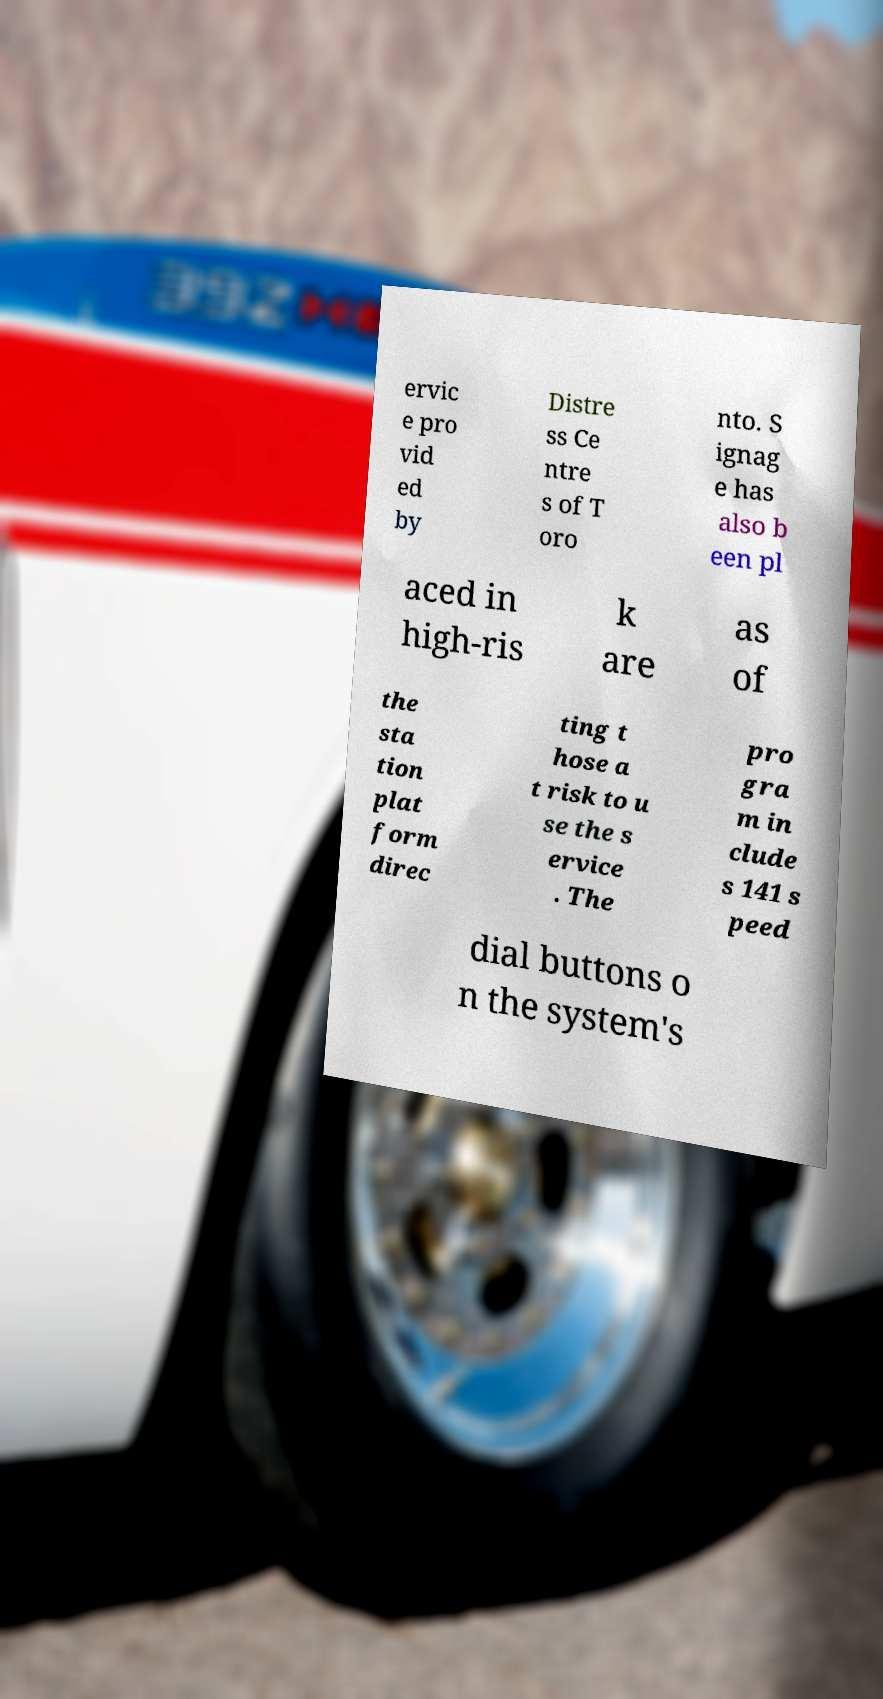Could you extract and type out the text from this image? ervic e pro vid ed by Distre ss Ce ntre s of T oro nto. S ignag e has also b een pl aced in high-ris k are as of the sta tion plat form direc ting t hose a t risk to u se the s ervice . The pro gra m in clude s 141 s peed dial buttons o n the system's 